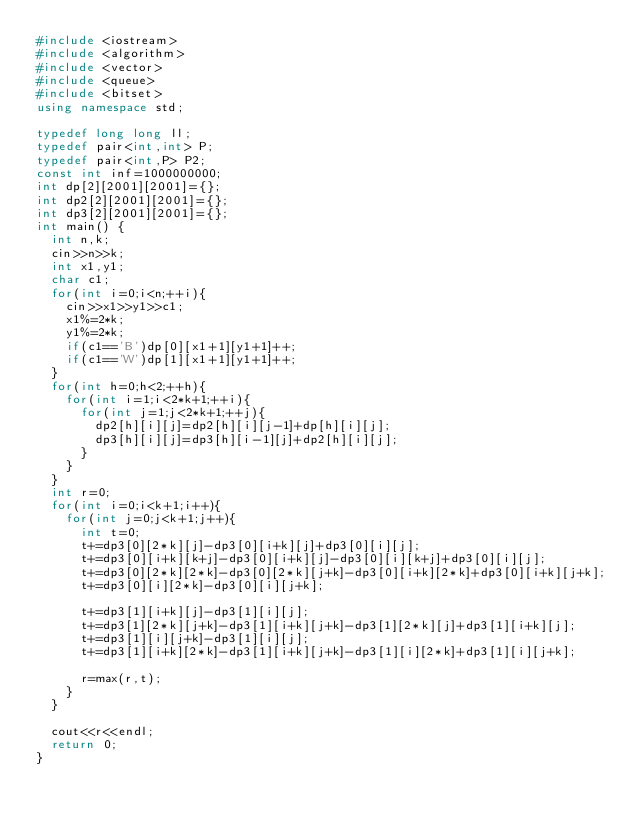Convert code to text. <code><loc_0><loc_0><loc_500><loc_500><_C++_>#include <iostream>
#include <algorithm>
#include <vector>
#include <queue>
#include <bitset>
using namespace std;

typedef long long ll;
typedef pair<int,int> P;
typedef pair<int,P> P2;
const int inf=1000000000;
int dp[2][2001][2001]={};
int dp2[2][2001][2001]={};
int dp3[2][2001][2001]={};
int main() {
	int n,k;
	cin>>n>>k;
	int x1,y1;
	char c1;
	for(int i=0;i<n;++i){
		cin>>x1>>y1>>c1;
		x1%=2*k;
		y1%=2*k;
		if(c1=='B')dp[0][x1+1][y1+1]++;
		if(c1=='W')dp[1][x1+1][y1+1]++;
	}
	for(int h=0;h<2;++h){
		for(int i=1;i<2*k+1;++i){
			for(int j=1;j<2*k+1;++j){
				dp2[h][i][j]=dp2[h][i][j-1]+dp[h][i][j];
				dp3[h][i][j]=dp3[h][i-1][j]+dp2[h][i][j];
			}
		}
	}
	int r=0;
	for(int i=0;i<k+1;i++){
		for(int j=0;j<k+1;j++){
			int t=0;
			t+=dp3[0][2*k][j]-dp3[0][i+k][j]+dp3[0][i][j];
			t+=dp3[0][i+k][k+j]-dp3[0][i+k][j]-dp3[0][i][k+j]+dp3[0][i][j];
			t+=dp3[0][2*k][2*k]-dp3[0][2*k][j+k]-dp3[0][i+k][2*k]+dp3[0][i+k][j+k];
			t+=dp3[0][i][2*k]-dp3[0][i][j+k];

			t+=dp3[1][i+k][j]-dp3[1][i][j];
			t+=dp3[1][2*k][j+k]-dp3[1][i+k][j+k]-dp3[1][2*k][j]+dp3[1][i+k][j];
			t+=dp3[1][i][j+k]-dp3[1][i][j];
			t+=dp3[1][i+k][2*k]-dp3[1][i+k][j+k]-dp3[1][i][2*k]+dp3[1][i][j+k];

			r=max(r,t);
		}
	}

	cout<<r<<endl;
	return 0;
}
</code> 